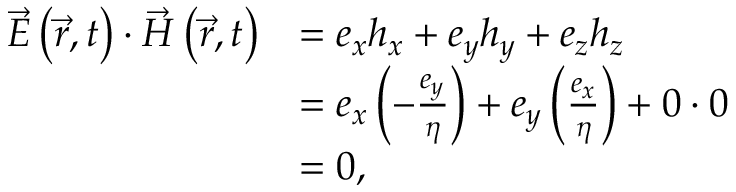<formula> <loc_0><loc_0><loc_500><loc_500>{ \begin{array} { r l } { { \vec { E } } \left ( { \vec { r } } , t \right ) \cdot { \vec { H } } \left ( { \vec { r } } , t \right ) } & { = e _ { x } h _ { x } + e _ { y } h _ { y } + e _ { z } h _ { z } } \\ & { = e _ { x } \left ( - { \frac { e _ { y } } { \eta } } \right ) + e _ { y } \left ( { \frac { e _ { x } } { \eta } } \right ) + 0 \cdot 0 } \\ & { = 0 , } \end{array} }</formula> 